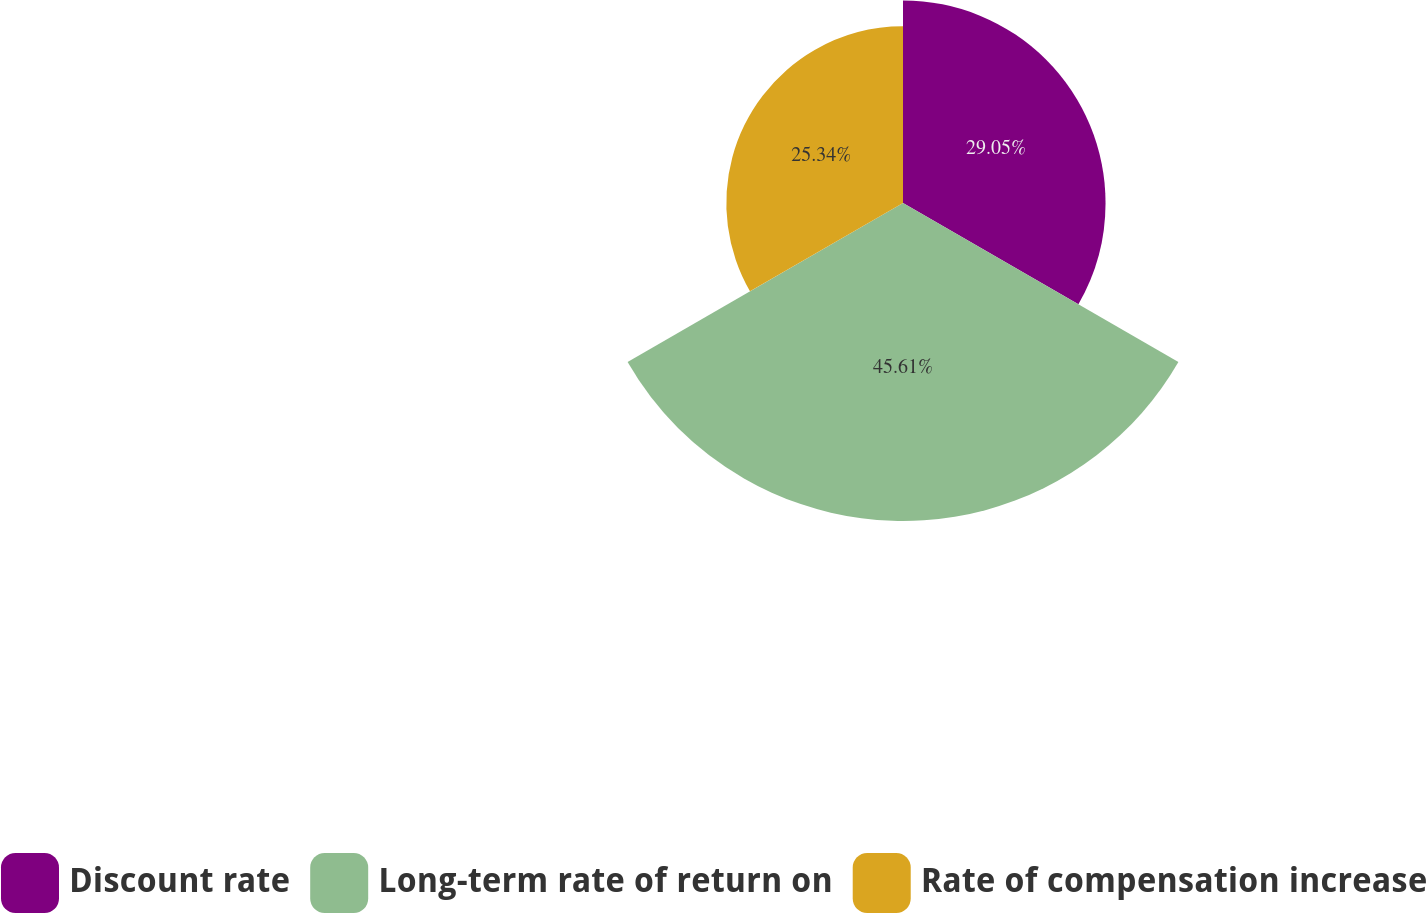<chart> <loc_0><loc_0><loc_500><loc_500><pie_chart><fcel>Discount rate<fcel>Long-term rate of return on<fcel>Rate of compensation increase<nl><fcel>29.05%<fcel>45.61%<fcel>25.34%<nl></chart> 